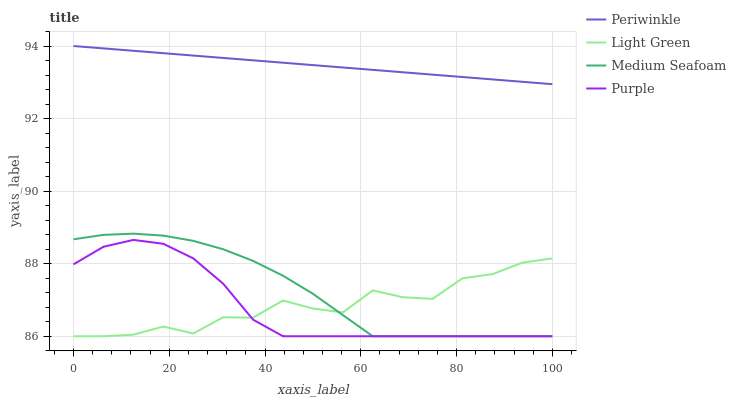Does Purple have the minimum area under the curve?
Answer yes or no. Yes. Does Periwinkle have the maximum area under the curve?
Answer yes or no. Yes. Does Medium Seafoam have the minimum area under the curve?
Answer yes or no. No. Does Medium Seafoam have the maximum area under the curve?
Answer yes or no. No. Is Periwinkle the smoothest?
Answer yes or no. Yes. Is Light Green the roughest?
Answer yes or no. Yes. Is Medium Seafoam the smoothest?
Answer yes or no. No. Is Medium Seafoam the roughest?
Answer yes or no. No. Does Periwinkle have the lowest value?
Answer yes or no. No. Does Medium Seafoam have the highest value?
Answer yes or no. No. Is Purple less than Periwinkle?
Answer yes or no. Yes. Is Periwinkle greater than Light Green?
Answer yes or no. Yes. Does Purple intersect Periwinkle?
Answer yes or no. No. 